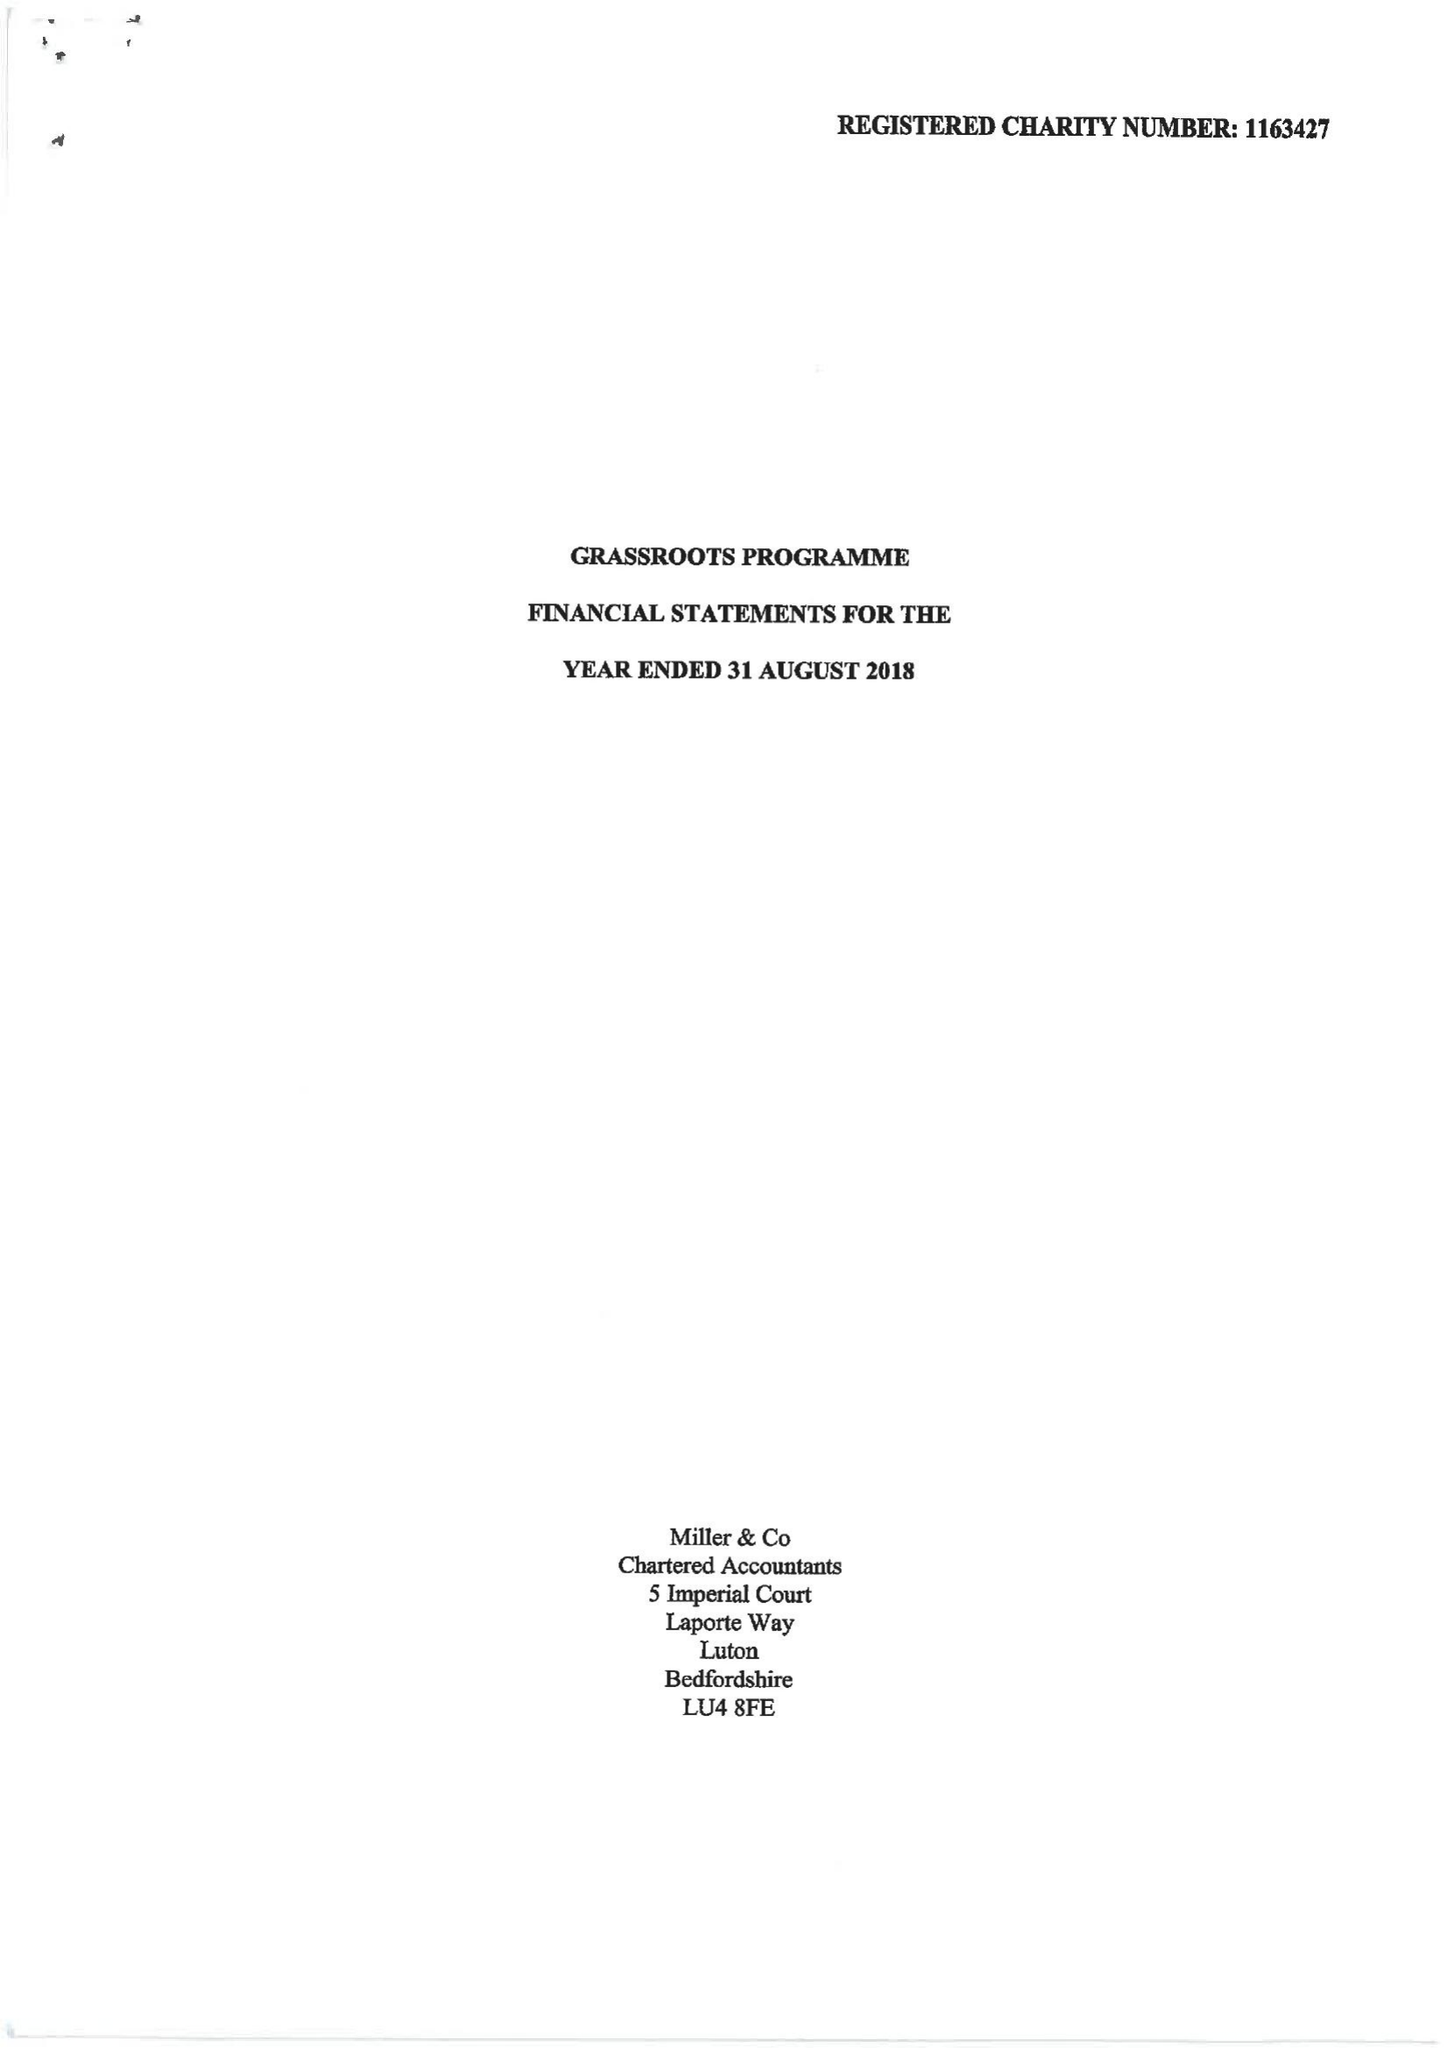What is the value for the address__postcode?
Answer the question using a single word or phrase. LU2 0BW 